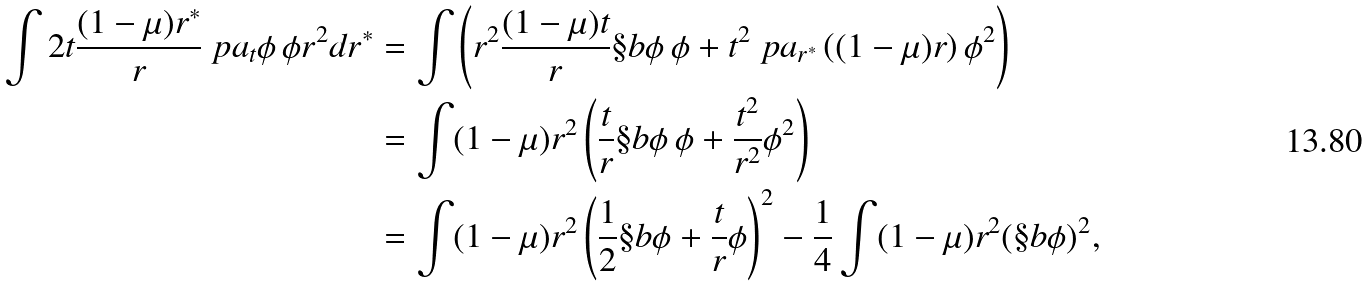Convert formula to latex. <formula><loc_0><loc_0><loc_500><loc_500>\int 2 t \frac { ( 1 - \mu ) r ^ { * } } r \ p a _ { t } \phi \, \phi r ^ { 2 } d r ^ { * } & = \int \left ( r ^ { 2 } \frac { ( 1 - \mu ) t } r \S b \phi \, \phi + t ^ { 2 } \ p a _ { r ^ { * } } \left ( ( 1 - \mu ) r \right ) \phi ^ { 2 } \right ) \\ & = \int ( 1 - \mu ) r ^ { 2 } \left ( \frac { t } r \S b \phi \, \phi + \frac { t ^ { 2 } } { r ^ { 2 } } \phi ^ { 2 } \right ) \\ & = \int ( 1 - \mu ) r ^ { 2 } \left ( \frac { 1 } { 2 } \S b \phi + \frac { t } { r } \phi \right ) ^ { 2 } - \frac { 1 } { 4 } \int ( 1 - \mu ) r ^ { 2 } ( \S b \phi ) ^ { 2 } ,</formula> 